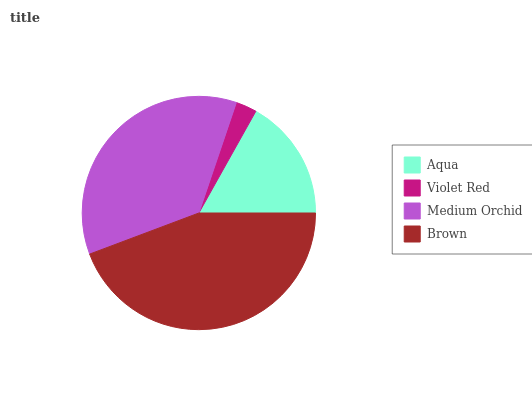Is Violet Red the minimum?
Answer yes or no. Yes. Is Brown the maximum?
Answer yes or no. Yes. Is Medium Orchid the minimum?
Answer yes or no. No. Is Medium Orchid the maximum?
Answer yes or no. No. Is Medium Orchid greater than Violet Red?
Answer yes or no. Yes. Is Violet Red less than Medium Orchid?
Answer yes or no. Yes. Is Violet Red greater than Medium Orchid?
Answer yes or no. No. Is Medium Orchid less than Violet Red?
Answer yes or no. No. Is Medium Orchid the high median?
Answer yes or no. Yes. Is Aqua the low median?
Answer yes or no. Yes. Is Brown the high median?
Answer yes or no. No. Is Violet Red the low median?
Answer yes or no. No. 